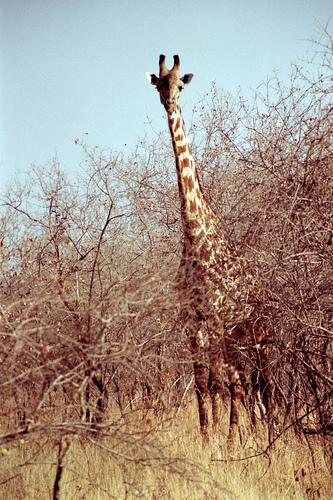What direction is the animal facing?
Quick response, please. Forward. What is this animal?
Be succinct. Giraffe. Is this animal eating?
Write a very short answer. No. 